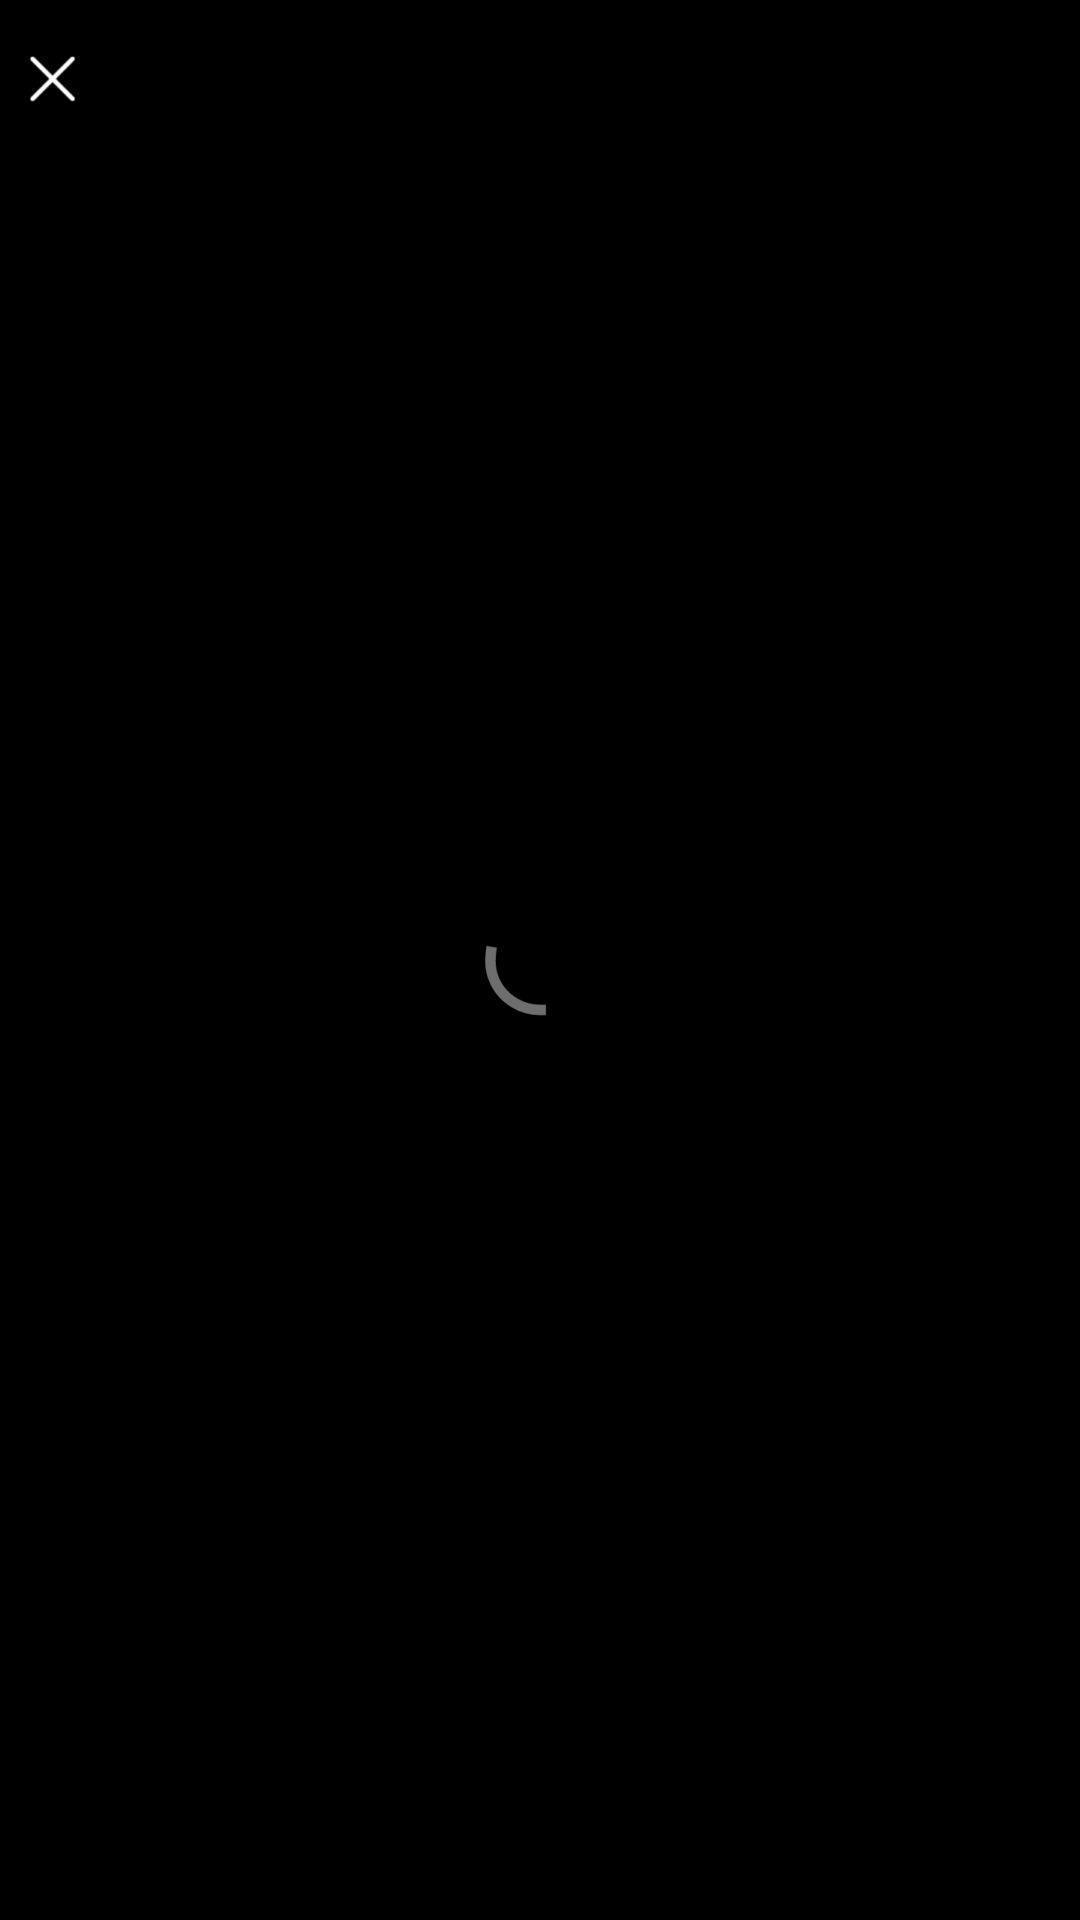What is the overall content of this screenshot? Screen showing a loading page. 